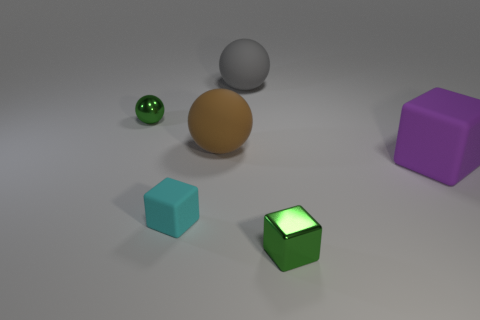Add 3 tiny cyan matte objects. How many objects exist? 9 Subtract all big brown rubber blocks. Subtract all tiny balls. How many objects are left? 5 Add 1 large purple things. How many large purple things are left? 2 Add 5 big objects. How many big objects exist? 8 Subtract 0 brown blocks. How many objects are left? 6 